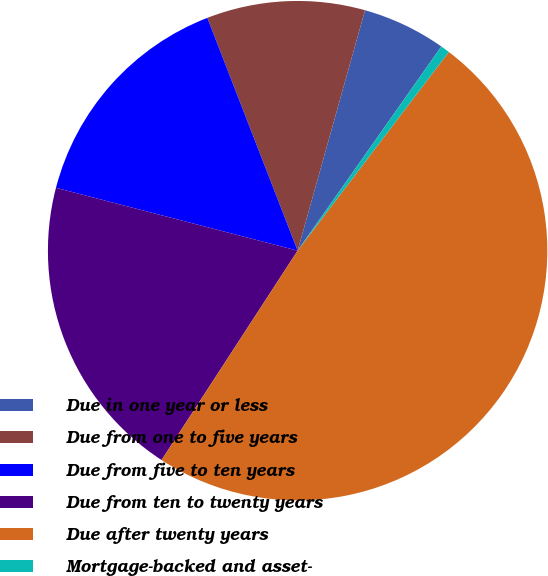Convert chart. <chart><loc_0><loc_0><loc_500><loc_500><pie_chart><fcel>Due in one year or less<fcel>Due from one to five years<fcel>Due from five to ten years<fcel>Due from ten to twenty years<fcel>Due after twenty years<fcel>Mortgage-backed and asset-<nl><fcel>5.41%<fcel>10.24%<fcel>15.06%<fcel>19.88%<fcel>48.82%<fcel>0.59%<nl></chart> 